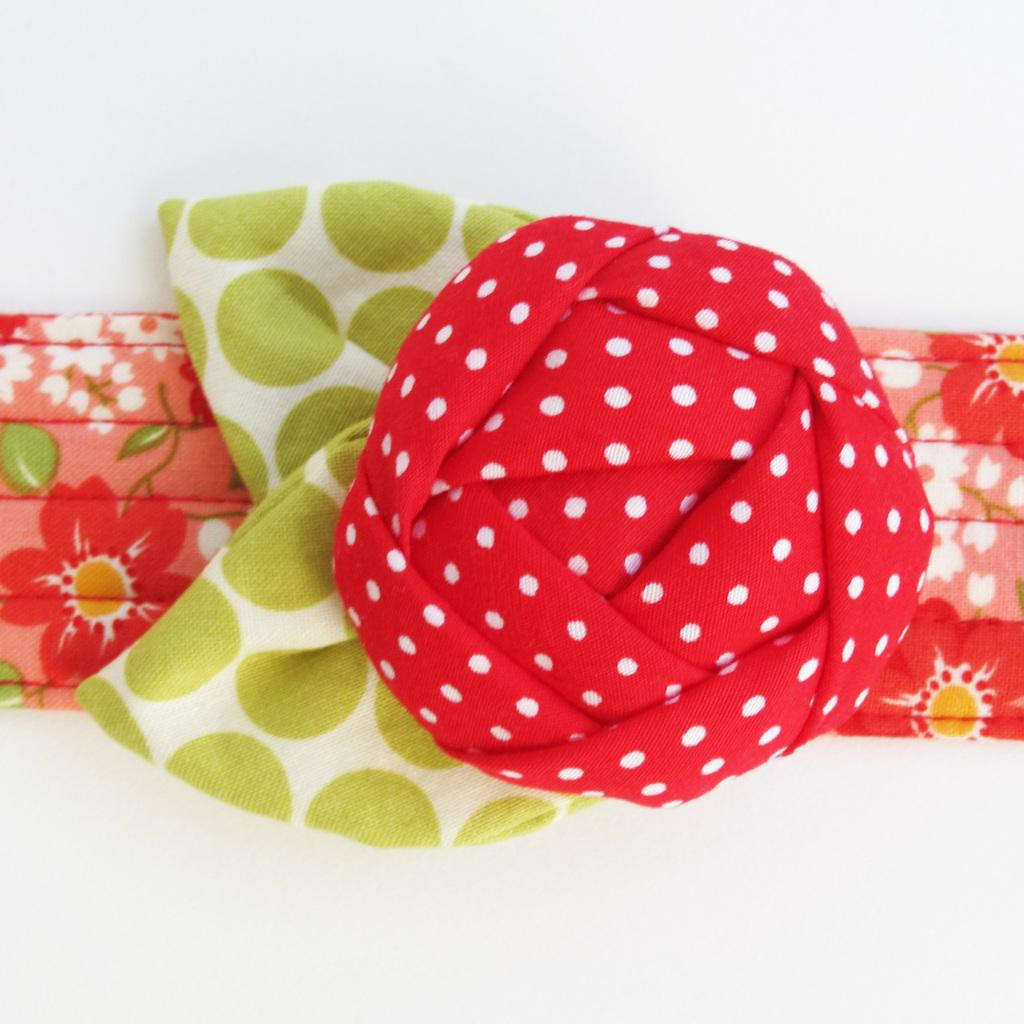What is the main subject of the image? The main subject of the image is clothes. Can you describe the location of the clothes in the image? The clothes are in the center of the image. What type of cushion is supporting the brain in the image? There is no cushion or brain present in the image; it only features clothes in the center. 